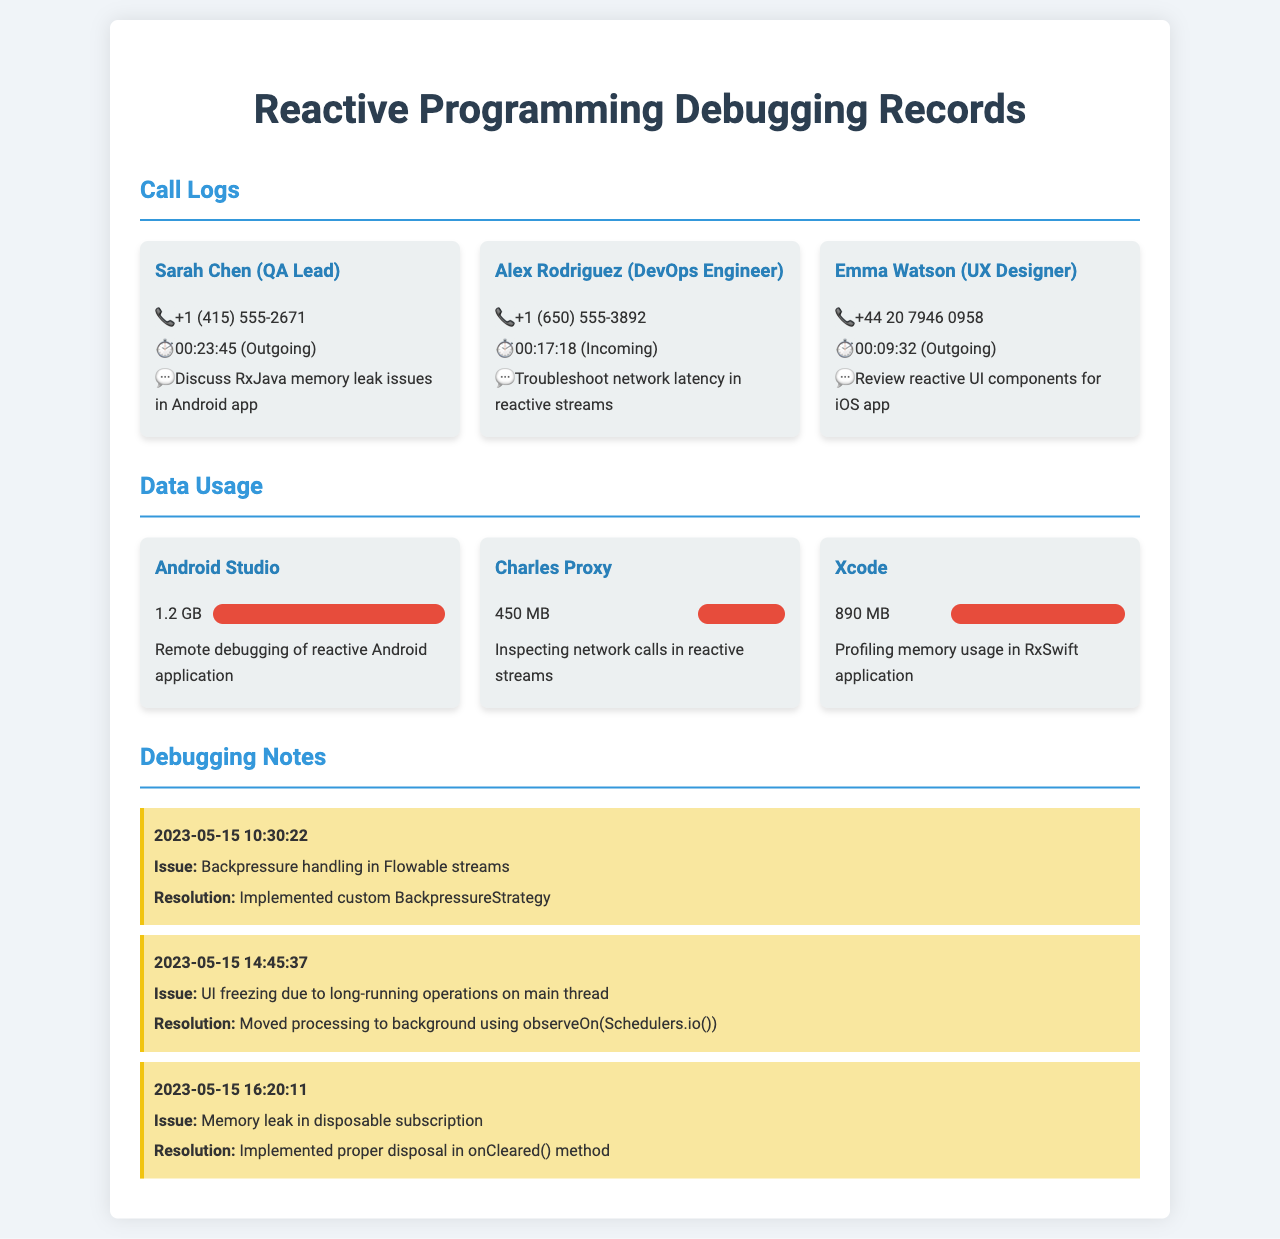What is the name of the QA Lead? The name of the QA Lead is mentioned in the call logs under Sarah Chen.
Answer: Sarah Chen How long was the call with Alex Rodriguez? The duration of the call with Alex Rodriguez is specified in the call logs as 00:17:18.
Answer: 00:17:18 What was the data usage for Android Studio? The data usage for Android Studio is reported in the document as 1.2 GB.
Answer: 1.2 GB What issue was resolved on May 15 at 16:20:11? The issue resolved at this time involves a memory leak in disposable subscriptions.
Answer: Memory leak in disposable subscription What percentage of data was used by Charles Proxy? Charles Proxy's data usage is represented in the document as 30%.
Answer: 30% Who discussed the RxJava memory leak issues? The individual discussing the RxJava memory leak issues is indicated in the call log as Sarah Chen.
Answer: Sarah Chen What was the resolution for UI freezing issues? The resolution provided in the document for UI freezing was moving processing to the background using observeOn(Schedulers.io()).
Answer: Moved processing to background What application was used for profiling memory in a Swift application? The application listed for profiling memory usage in a Swift application is Xcode.
Answer: Xcode 